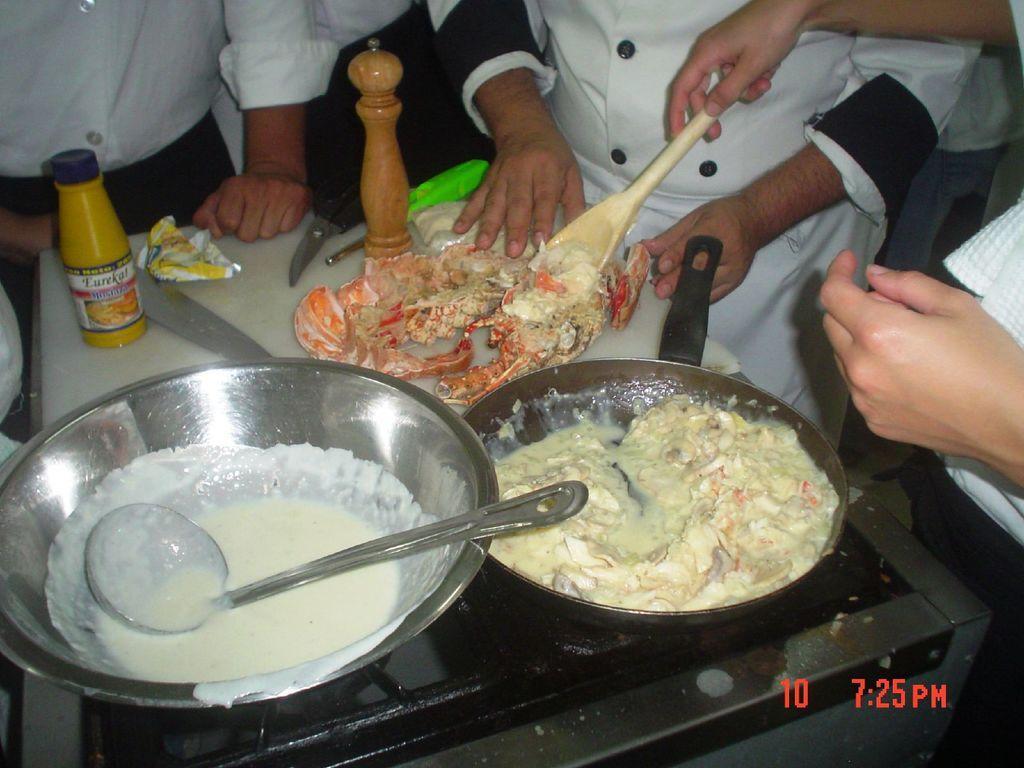Describe this image in one or two sentences. In this image there are people, stove, pan, container, bottle, spatula, knife, scissors, food and objects. Among them one person is holding a spatula. Something is written at the bottom right side of the image. 